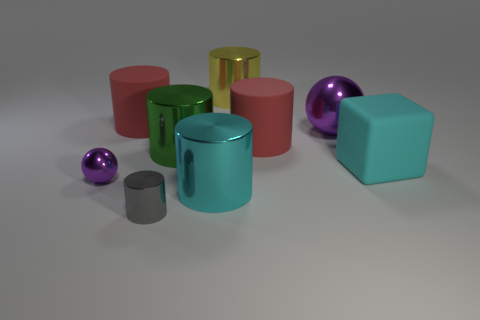What material is the big red object on the right side of the large thing that is in front of the tiny metal ball?
Offer a very short reply. Rubber. What number of matte objects are cyan cubes or large red things?
Provide a short and direct response. 3. There is another tiny shiny object that is the same shape as the green metallic object; what is its color?
Your response must be concise. Gray. How many cylinders are the same color as the block?
Provide a short and direct response. 1. There is a large ball that is in front of the yellow shiny thing; is there a green thing that is behind it?
Ensure brevity in your answer.  No. What number of things are in front of the big purple ball and to the left of the green metal object?
Keep it short and to the point. 2. What number of large objects are the same material as the large block?
Offer a very short reply. 2. What is the size of the purple metallic sphere left of the red thing that is left of the large green metal cylinder?
Offer a terse response. Small. Is there a big matte thing that has the same shape as the small gray object?
Offer a terse response. Yes. There is a red cylinder that is left of the large green metal cylinder; does it have the same size as the red matte object on the right side of the green thing?
Ensure brevity in your answer.  Yes. 